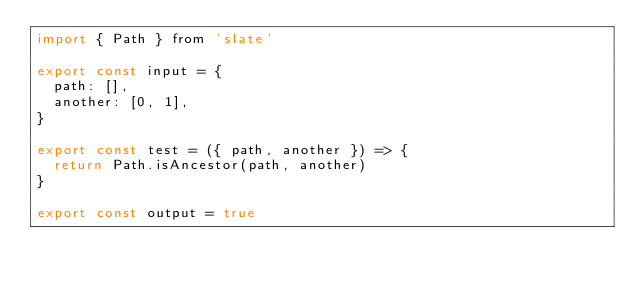Convert code to text. <code><loc_0><loc_0><loc_500><loc_500><_JavaScript_>import { Path } from 'slate'

export const input = {
  path: [],
  another: [0, 1],
}

export const test = ({ path, another }) => {
  return Path.isAncestor(path, another)
}

export const output = true
</code> 